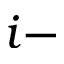Convert formula to latex. <formula><loc_0><loc_0><loc_500><loc_500>i -</formula> 